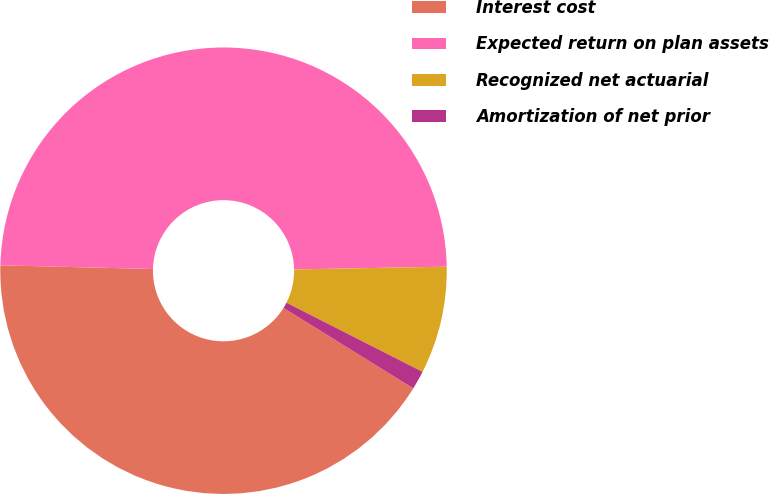Convert chart. <chart><loc_0><loc_0><loc_500><loc_500><pie_chart><fcel>Interest cost<fcel>Expected return on plan assets<fcel>Recognized net actuarial<fcel>Amortization of net prior<nl><fcel>41.55%<fcel>49.32%<fcel>7.77%<fcel>1.35%<nl></chart> 